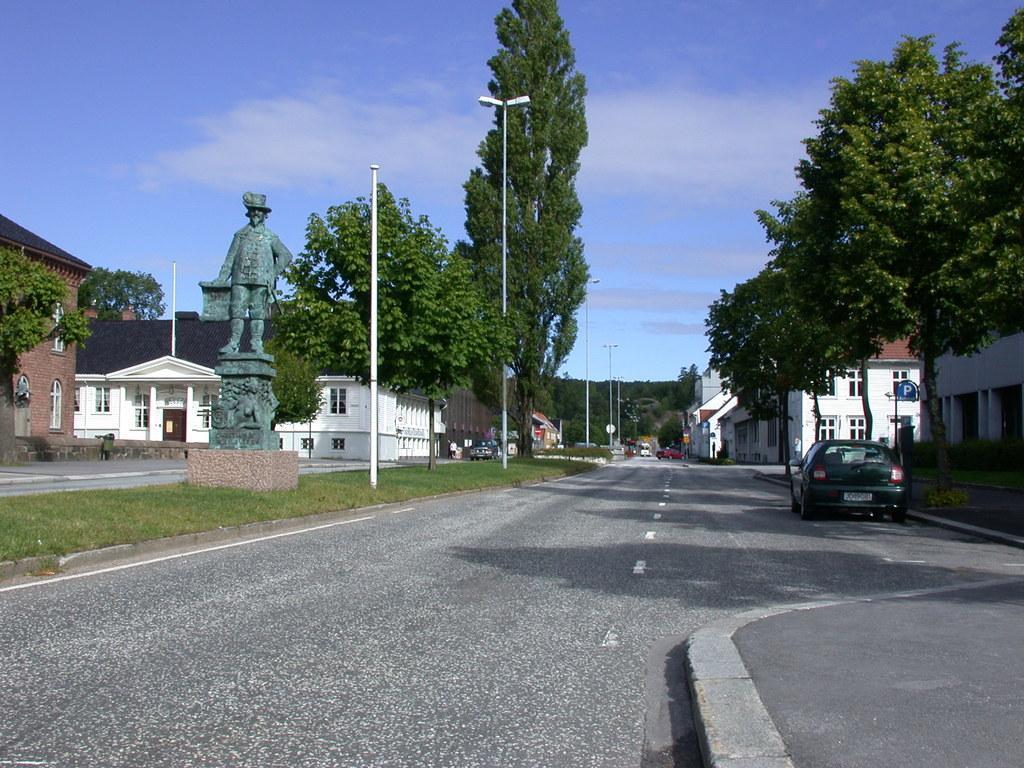Could you give a brief overview of what you see in this image? In this image I can see few vehicles, buildings in white and brown color, trees in green color, light poles. In front I can see the statue. In the background the sky is in blue and white color. 